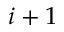Convert formula to latex. <formula><loc_0><loc_0><loc_500><loc_500>i + 1</formula> 